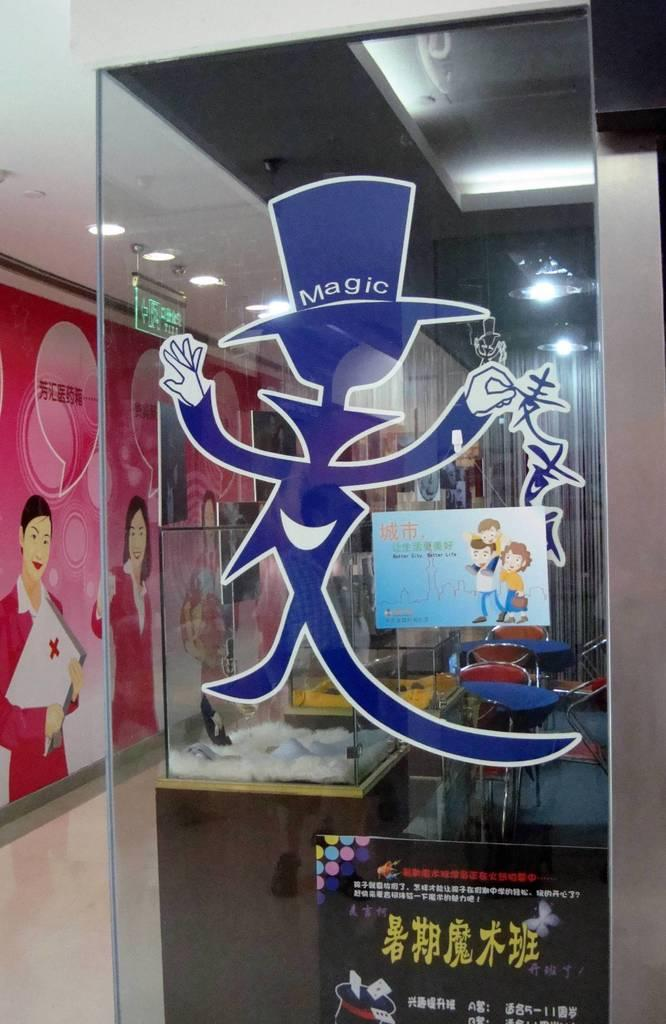<image>
Create a compact narrative representing the image presented. A blue figure with a large top hat has "magic" written on t. 